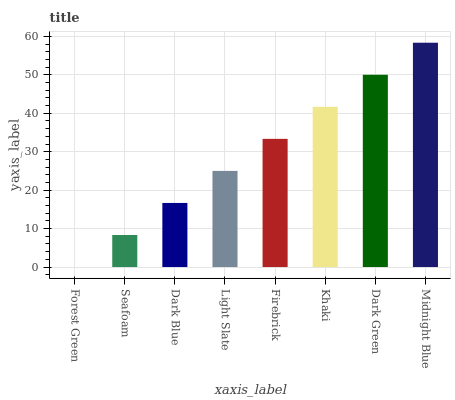Is Forest Green the minimum?
Answer yes or no. Yes. Is Midnight Blue the maximum?
Answer yes or no. Yes. Is Seafoam the minimum?
Answer yes or no. No. Is Seafoam the maximum?
Answer yes or no. No. Is Seafoam greater than Forest Green?
Answer yes or no. Yes. Is Forest Green less than Seafoam?
Answer yes or no. Yes. Is Forest Green greater than Seafoam?
Answer yes or no. No. Is Seafoam less than Forest Green?
Answer yes or no. No. Is Firebrick the high median?
Answer yes or no. Yes. Is Light Slate the low median?
Answer yes or no. Yes. Is Khaki the high median?
Answer yes or no. No. Is Dark Green the low median?
Answer yes or no. No. 